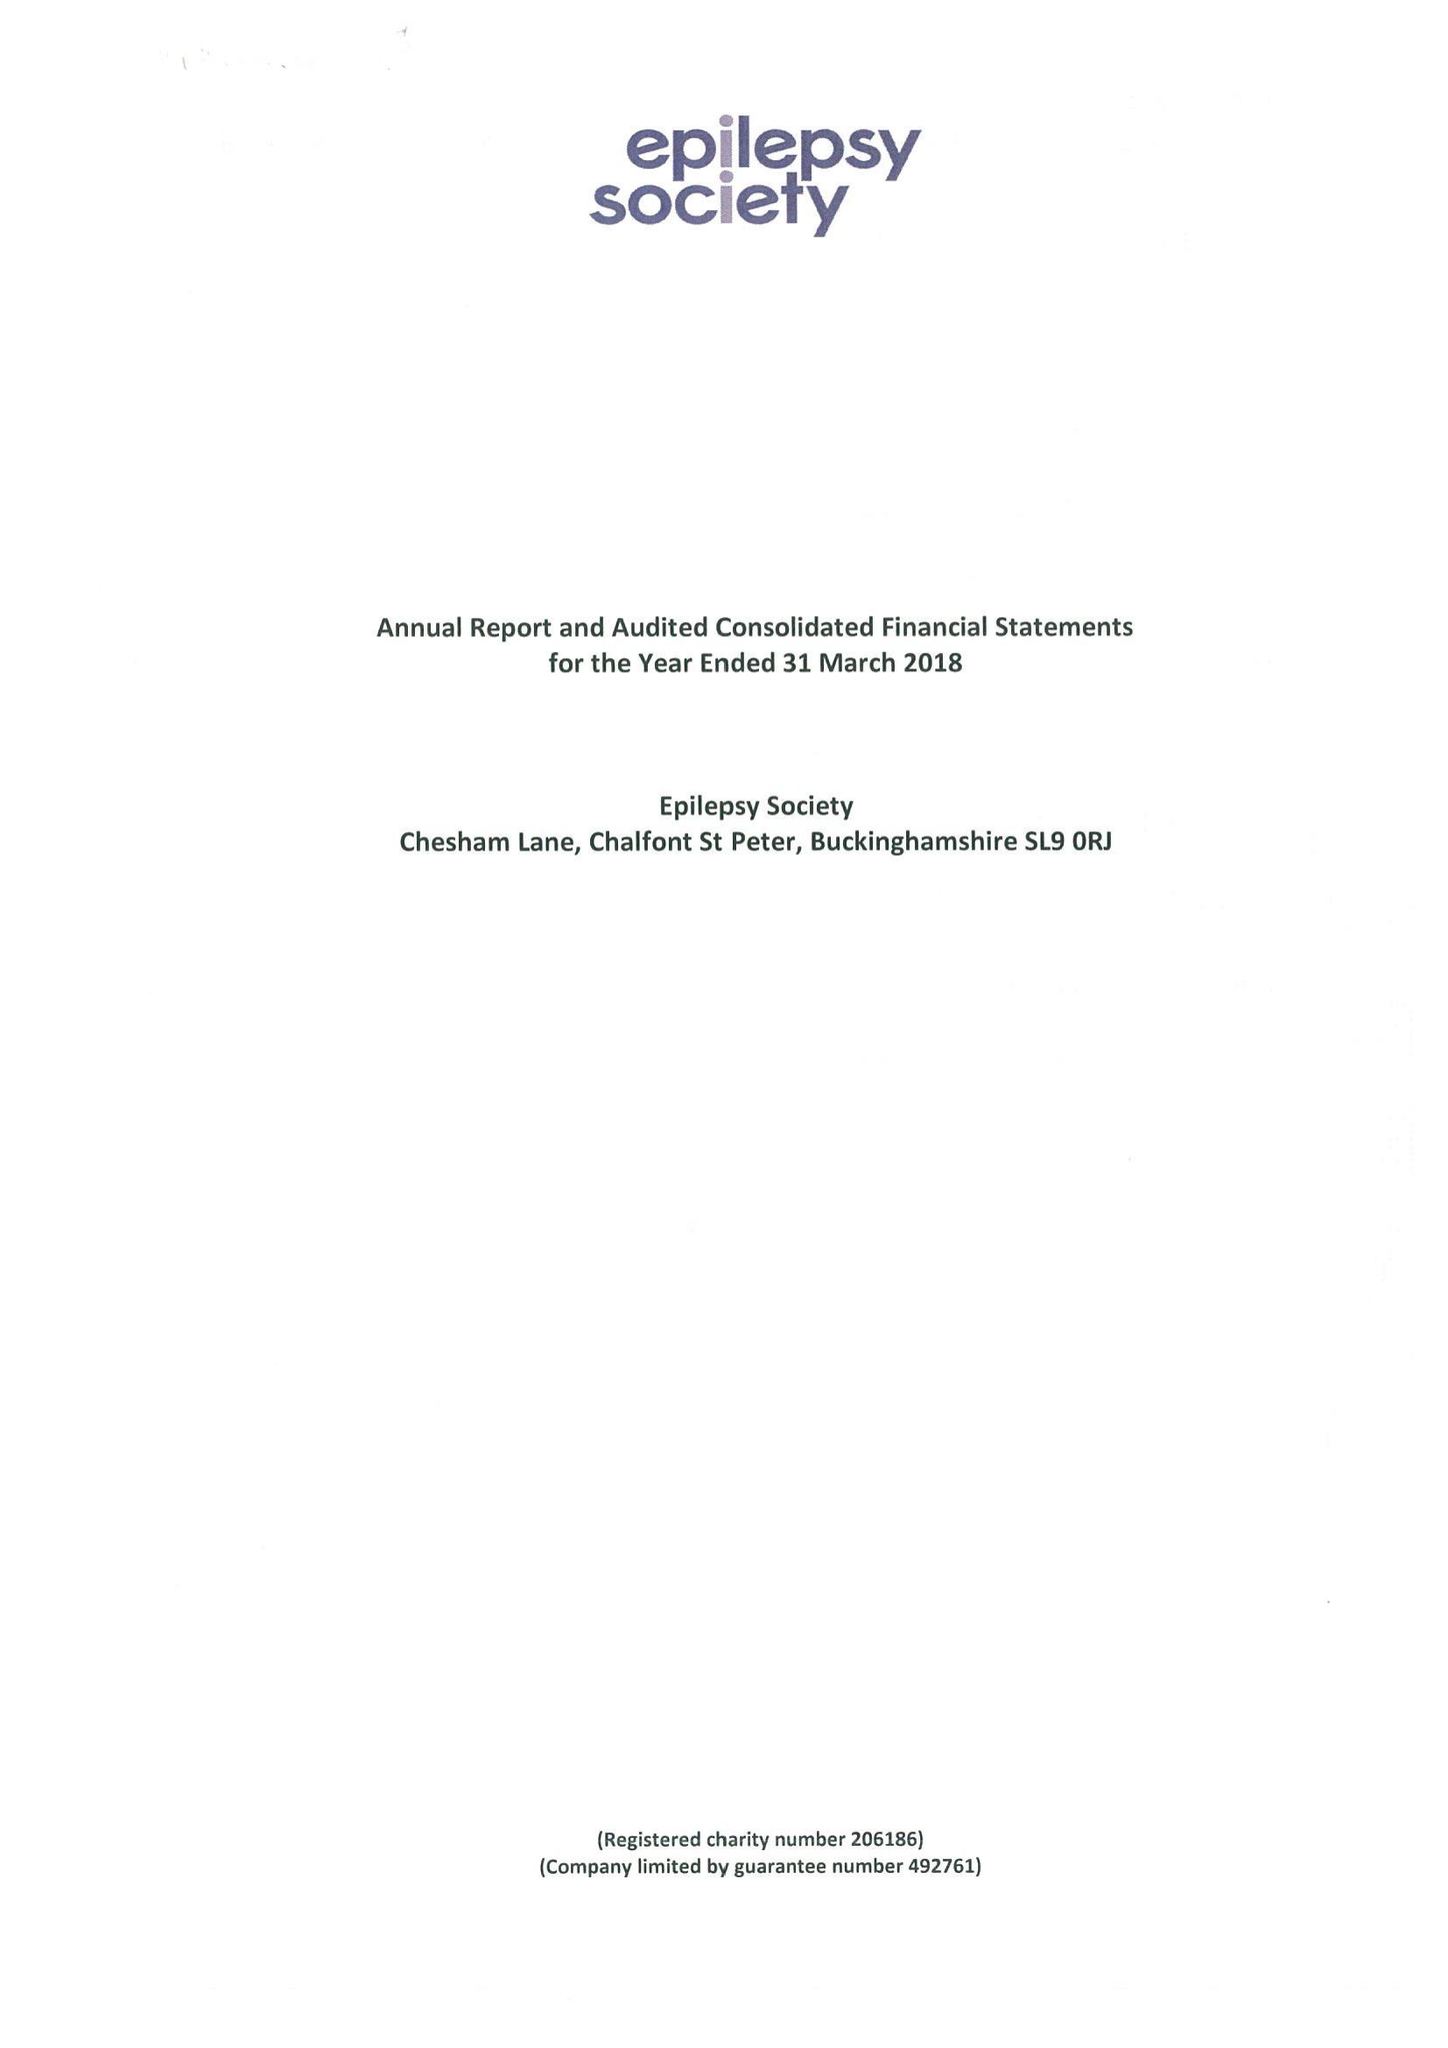What is the value for the income_annually_in_british_pounds?
Answer the question using a single word or phrase. 17174000.00 